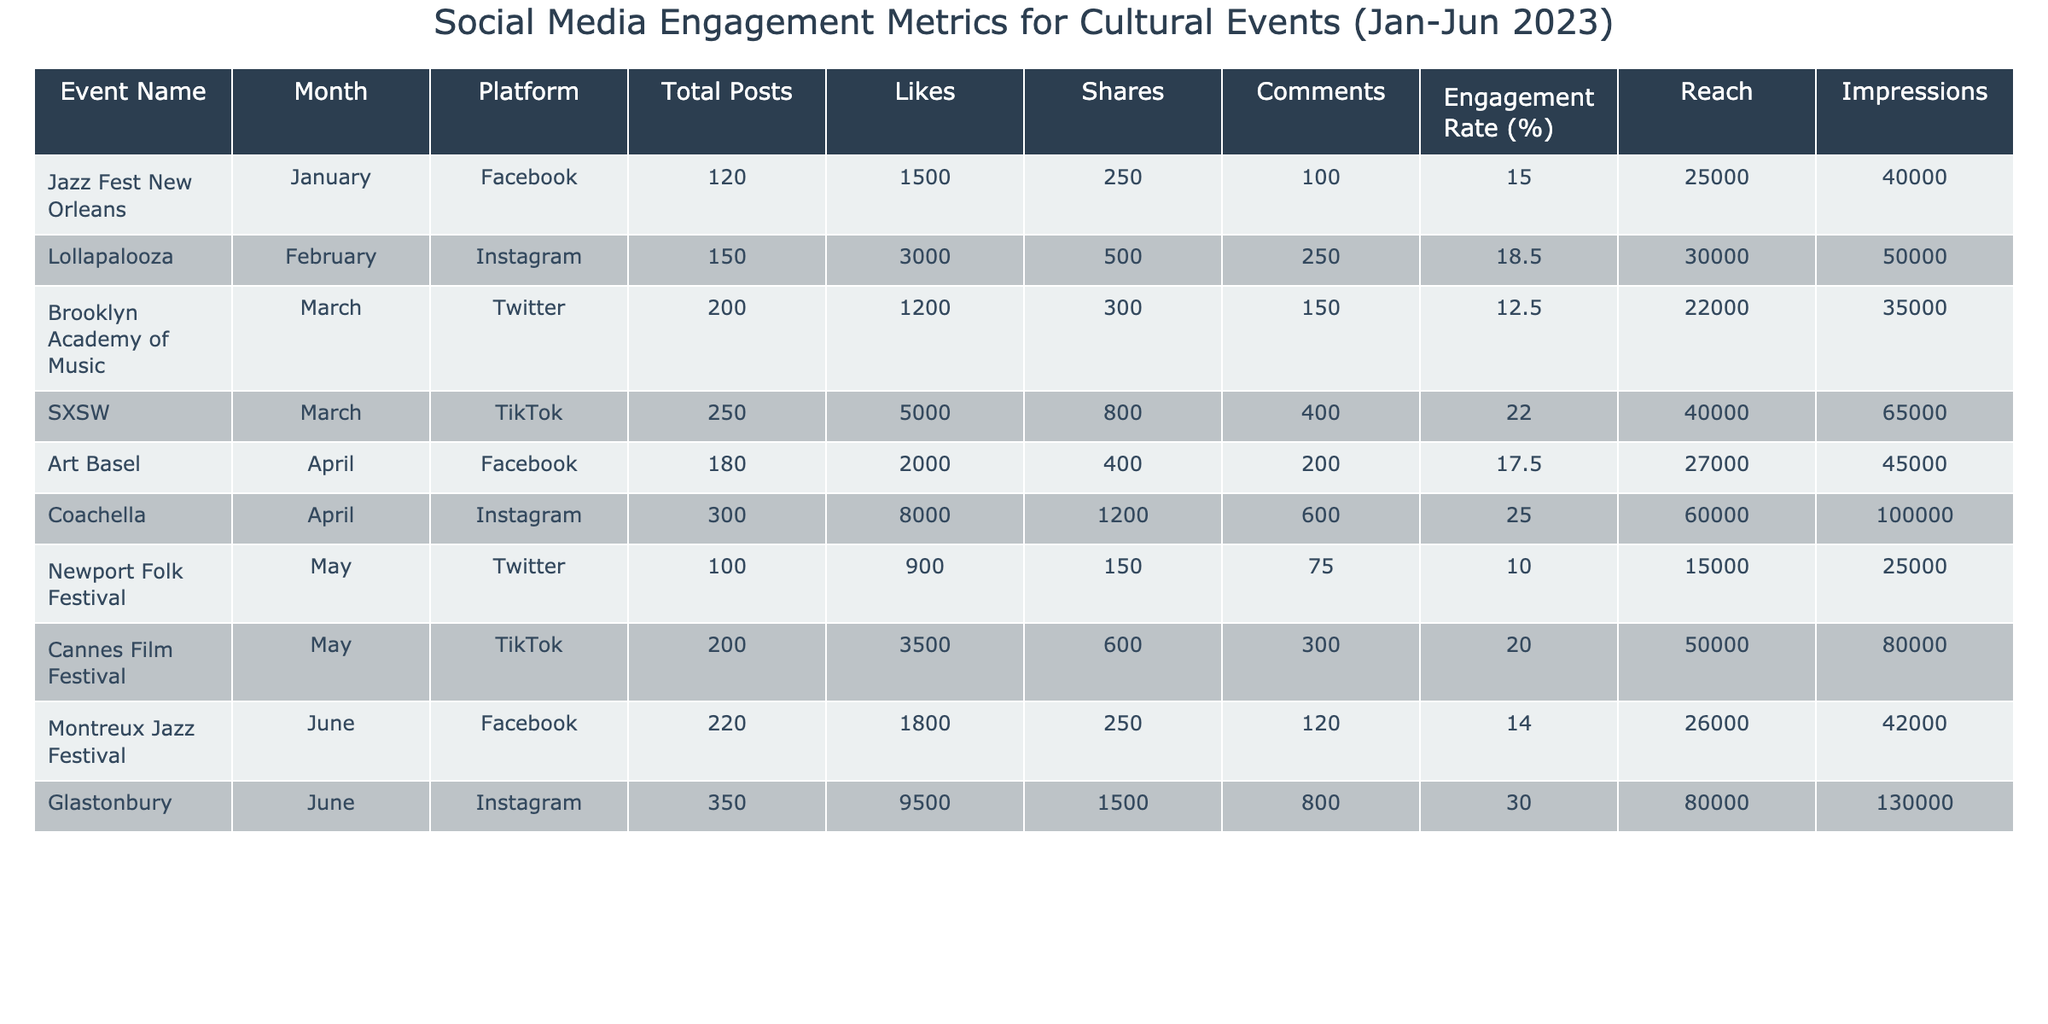What is the engagement rate of Coachella in April? The engagement rate for Coachella is listed directly in the table under April's row for Instagram, which shows an engagement rate of 25.0%.
Answer: 25.0% Which event had the highest number of likes in June? In June, Glastonbury had the highest number of likes with 9500, compared to Montreux Jazz Festival, which had 1800 likes.
Answer: Glastonbury How many total posts were made for Jazz Fest New Orleans in January? Jazz Fest New Orleans has a total of 120 posts listed for January in the table.
Answer: 120 What is the average number of shares for events held in March? In March, there are two events: Brooklyn Academy of Music with 300 shares and SXSW with 800 shares. The average is calculated as (300 + 800) / 2 = 550.
Answer: 550 Did any TikTok event in May have a higher engagement rate than the one in March? The Cannes Film Festival had a 20.0% engagement rate in May while SXSW in March had a 22.0% engagement rate, which is higher. Therefore, the answer is no.
Answer: No Which platform had the highest total reach for cultural events in April? In April, Coachella on Instagram had the highest reach, with 60000, compared to Art Basel on Facebook, which had a reach of 27000.
Answer: Instagram What is the total number of comments across all events in May? The total number of comments in May is calculated by adding Newport Folk Festival's 75 comments and Cannes Film Festival's 300 comments: 75 + 300 = 375.
Answer: 375 Which month had the least engagement rate and what was it? May had the Newport Folk Festival with the least engagement rate of 10.0%, which is the lowest among all months listed in the table.
Answer: May, 10.0% How does the total number of impressions for all events in June compare to total impressions in April? In June, the total impressions are Glastonbury's 130000 + Montreux Jazz Festival's 42000 = 172000; in April, it's Coachella's 100000 + Art Basel's 45000 = 145000. Thus, June has more impressions than April.
Answer: June > April What is the total engagement rate across all events from January to June? To find the total engagement rate, sum all individual engagement rates (15.0 + 18.5 + 12.5 + 22.0 + 17.5 + 25.0 + 10.0 + 20.0 + 14.0 + 30.0) = 180.5 and then divide by the number of events (10) to get an average of 18.05%.
Answer: 18.05% 